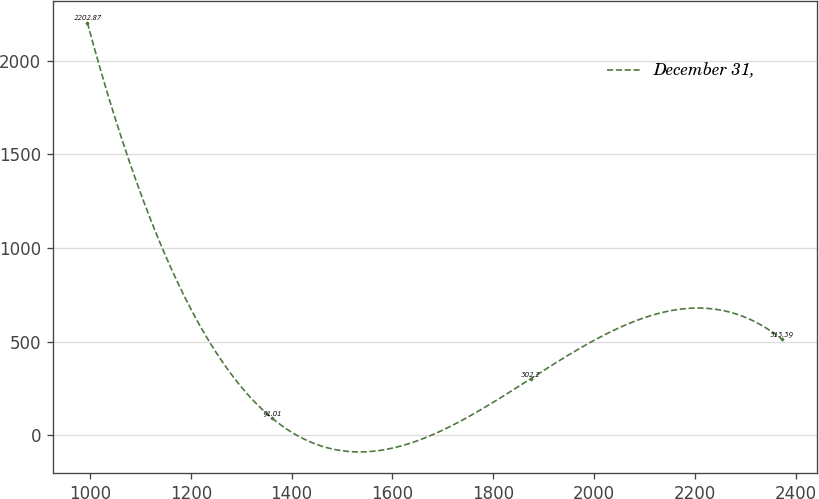<chart> <loc_0><loc_0><loc_500><loc_500><line_chart><ecel><fcel>December 31,<nl><fcel>994.7<fcel>2202.87<nl><fcel>1361.56<fcel>91.01<nl><fcel>1874.26<fcel>302.2<nl><fcel>2372.68<fcel>513.39<nl></chart> 